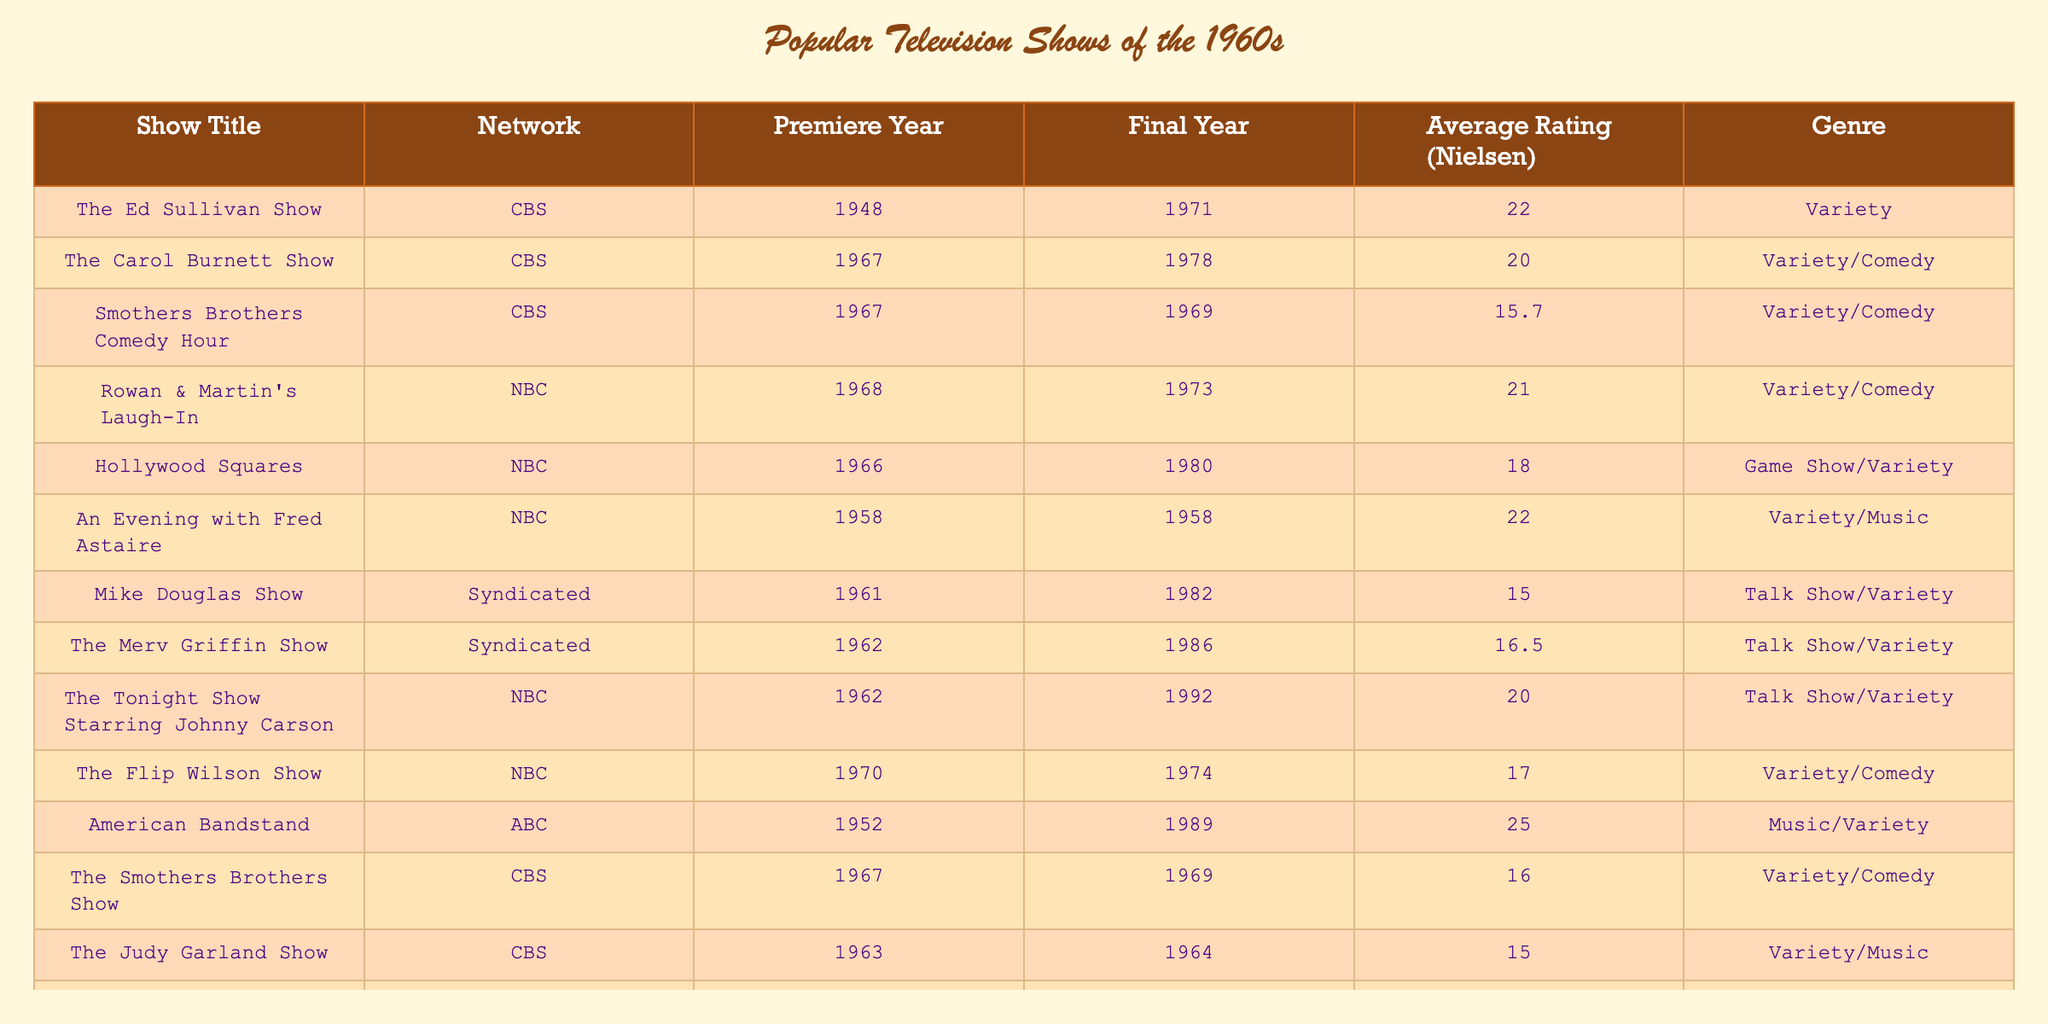What was the average rating of "The Ed Sullivan Show"? The table shows that "The Ed Sullivan Show" had an average Nielsen rating of 22.0.
Answer: 22.0 Which show has the highest average rating? The data indicates that "American Bandstand" has the highest average rating of 25.0.
Answer: 25.0 Did "The Judy Garland Show" last longer than one year? The table states that "The Judy Garland Show" premiered in 1963 and ended in 1964, meaning it lasted only one year. Therefore, the answer is no.
Answer: No What is the difference between the average ratings of "Rowan & Martin's Laugh-In" and "The Smothers Brothers Comedy Hour"? "Rowan & Martin's Laugh-In" has an average rating of 21.0, while "The Smothers Brothers Comedy Hour" has a rating of 15.7. The difference is 21.0 - 15.7 = 5.3.
Answer: 5.3 How many shows in the table aired on CBS? From the data, the shows that aired on CBS are "The Ed Sullivan Show," "The Carol Burnett Show," "The Smothers Brothers Show," and "The Judy Garland Show," totaling four shows.
Answer: 4 Is it true that all shown shows with an average rating above 20.0 are variety shows? The shows with ratings above 20.0 are "American Bandstand" (music variety), "The Ed Sullivan Show" (variety), "Rowan & Martin's Laugh-In" (variety/comedy), and "The Carol Burnett Show" (variety/comedy). The only exception is "American Bandstand," which is primarily a music show, thus the answer is false.
Answer: No What was the average Nielsen rating of variety/comedy shows in the table? The variety/comedy shows and their ratings are: "The Carol Burnett Show" (20.0), "Smothers Brothers Comedy Hour" (15.7), "Rowan & Martin's Laugh-In" (21.0), "The Flip Wilson Show" (17.0), and "The Smothers Brothers Show" (16.0). The average is (20.0 + 15.7 + 21.0 + 17.0 + 16.0) / 5 = 18.9.
Answer: 18.9 What genre did "The Tonight Show Starring Johnny Carson" belong to? According to the table, "The Tonight Show Starring Johnny Carson" is listed under the genre of Talk Show/Variety.
Answer: Talk Show/Variety Which network aired the most shows listed in the table? By examining the table, CBS aired a total of 5 shows: "The Ed Sullivan Show," "The Carol Burnett Show," "The Smothers Brothers Show," "The Judy Garland Show," and "The Dean Martin Show." Therefore, CBS has the most shows listed.
Answer: CBS What is the average rating of shows that aired on NBC? The NBC shows and their ratings are: "Rowan & Martin's Laugh-In" (21.0), "Hollywood Squares" (18.0), "The Tonight Show Starring Johnny Carson" (20.0), "The Flip Wilson Show" (17.0). The average is (21.0 + 18.0 + 20.0 + 17.0) / 4 = 19.0.
Answer: 19.0 How many variety/music shows had ratings below 16.0? Looking at the table, "The Judy Garland Show" (15.0) and "The Smothers Brothers Show" (16.0) are the only variety/music shows below 16.0, totaling one show.
Answer: 1 